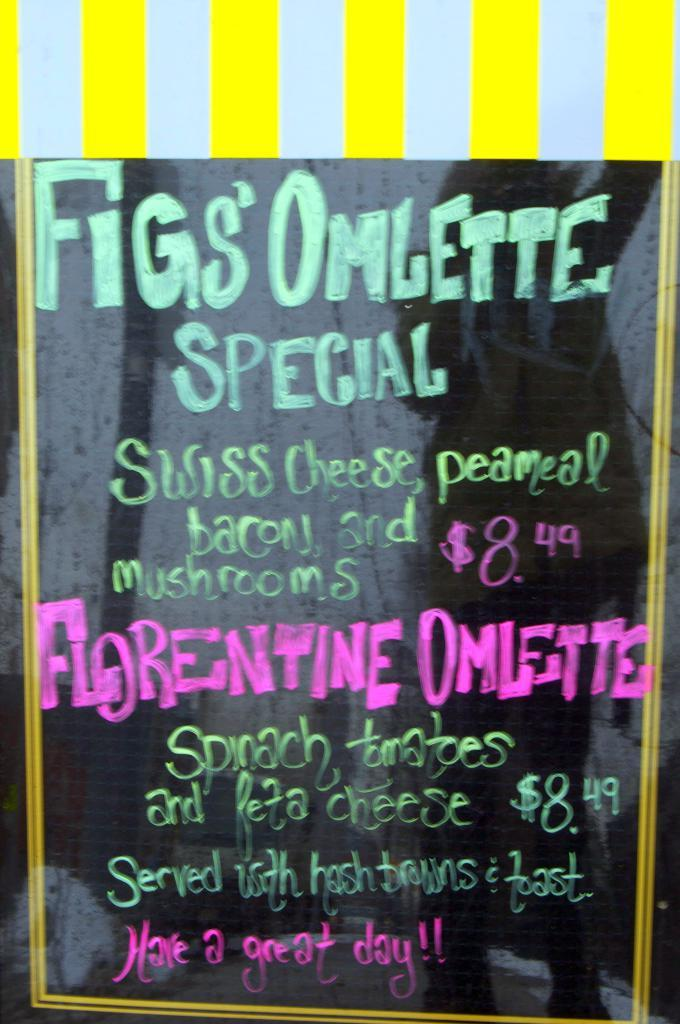<image>
Render a clear and concise summary of the photo. Brightly colored FIgs Omelette Special sign outside of the restaurant. 